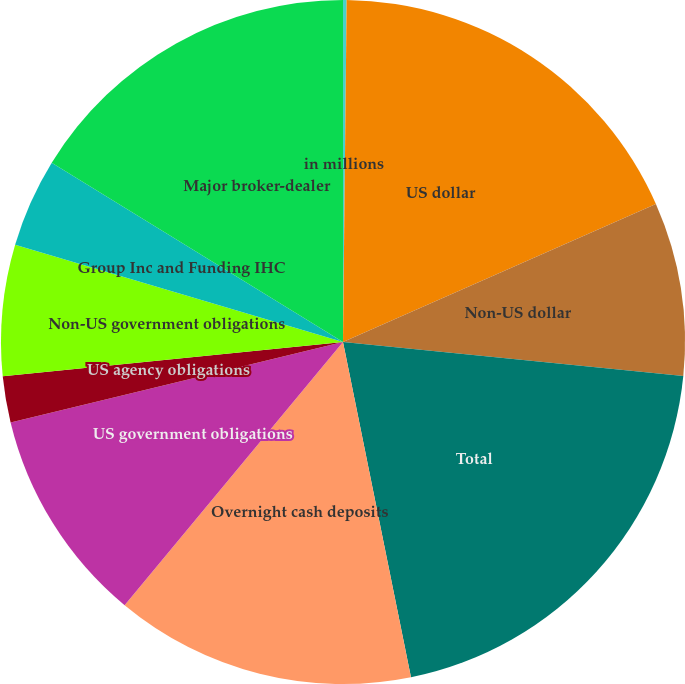Convert chart. <chart><loc_0><loc_0><loc_500><loc_500><pie_chart><fcel>in millions<fcel>US dollar<fcel>Non-US dollar<fcel>Total<fcel>Overnight cash deposits<fcel>US government obligations<fcel>US agency obligations<fcel>Non-US government obligations<fcel>Group Inc and Funding IHC<fcel>Major broker-dealer<nl><fcel>0.17%<fcel>18.22%<fcel>8.2%<fcel>20.23%<fcel>14.21%<fcel>10.2%<fcel>2.18%<fcel>6.19%<fcel>4.19%<fcel>16.22%<nl></chart> 